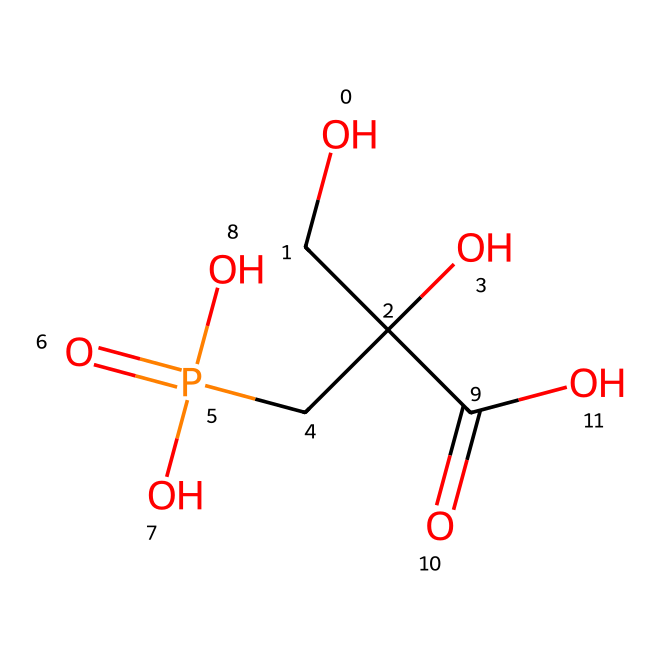What is the molecular formula of glyphosate? To find the molecular formula, we can count the number of each type of atom in the chemical structure. The SMILES represents carbons (C), hydrogens (H), oxygens (O), and phosphorus (P). Counting them gives us 3 carbons, 8 hydrogens, 1 phosphorus, and 4 oxygens, leading to the formula C3H8NO5P.
Answer: C3H8NO5P How many oxygen atoms are present in glyphosate? By analyzing the SMILES structure, we see the letter "O" appears four times, which indicates there are four oxygen atoms in glyphosate.
Answer: 4 What type of functional groups are present in glyphosate? The glyphosate structure contains several functional groups such as a carboxylic acid group (–COOH) and a phosphonic acid group (–PO3H2). These can be identified by looking at the parts of the structure where a carbon or phosphorus is bonded to oxygen and hydroxyl groups.
Answer: carboxylic acid, phosphonic acid What is the significance of phosphorus in glyphosate’s structure? Phosphorus is crucial in glyphosate because it imparts the herbicidal activity and is part of the phosphonic acid group. This is significant in understanding how glyphosate acts on plants, interacting with specific enzymes that contribute to the herbicidal effect.
Answer: herbicidal activity How does the glyphosate structure contribute to its herbicidal properties? Glyphosate inhibits a specific enzyme pathway (the shikimic acid pathway) in plants and some microbes, which is vital for synthesizing important amino acids. The presence of the phosphonic acid functional group allows glyphosate to be absorbed by plants effectively, leading to its herbicidal properties.
Answer: inhibits enzyme pathway What is the total number of atoms in glyphosate? To find the total number of atoms, we sum up all the different types: 3 carbons (C) + 8 hydrogens (H) + 1 phosphorus (P) + 4 oxygens (O) = 16 atoms in total.
Answer: 16 How does glyphosate’s structure allow for selective weed control? Glyphosate specifically targets the shikimic acid pathway, which is not present in animals. The unique arrangement of atoms in glyphosate, including its functional groups, permits it to interact with plant-specific enzymes, allowing for selective targeting of weeds while sparing non-target plants (like many crops).
Answer: selective targeting 